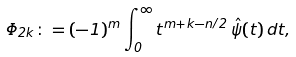Convert formula to latex. <formula><loc_0><loc_0><loc_500><loc_500>\Phi _ { 2 k } \colon = ( - 1 ) ^ { m } \int _ { 0 } ^ { \infty } t ^ { m + k - n / 2 } \, \hat { \psi } ( t ) \, d t ,</formula> 